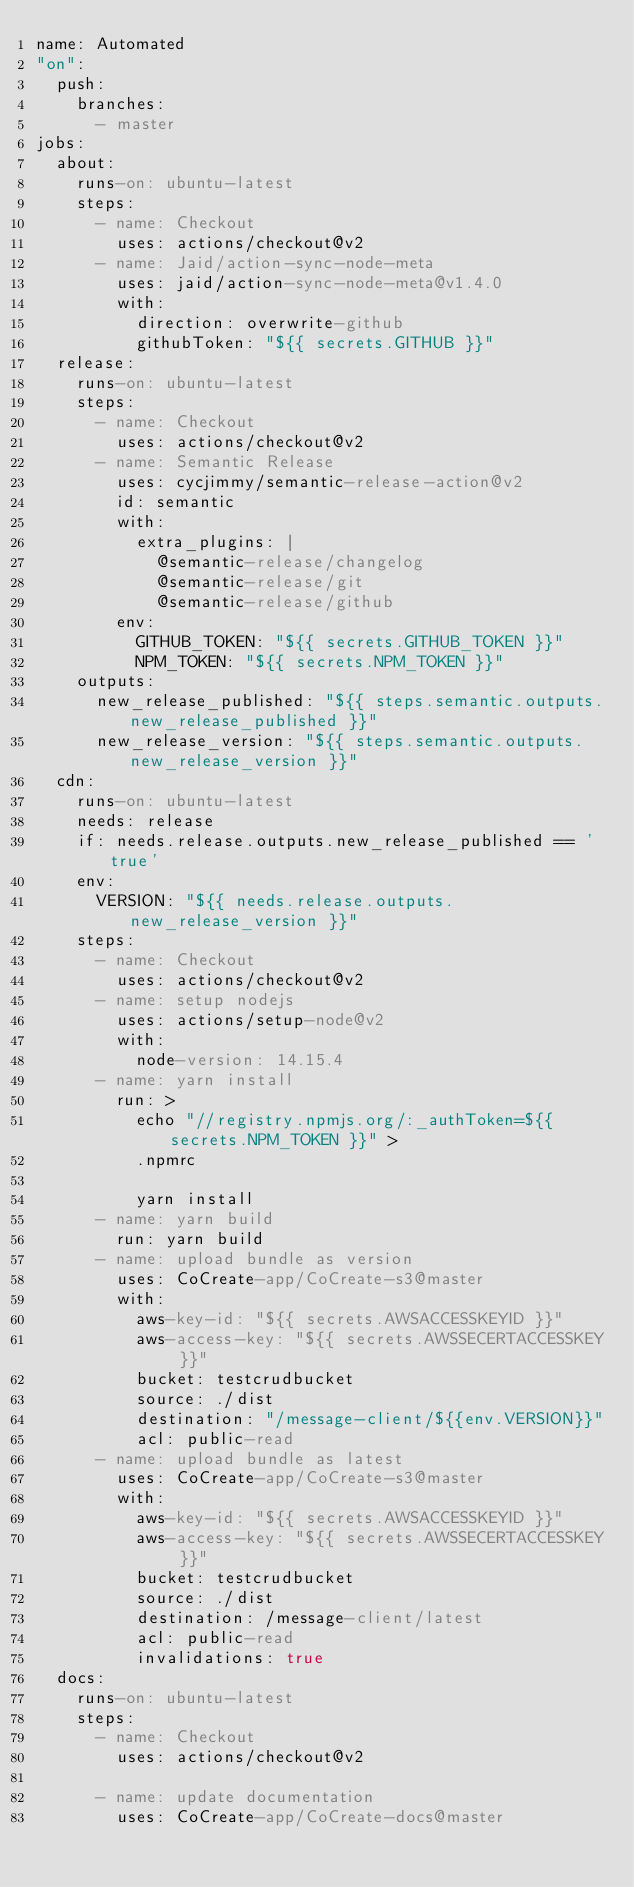Convert code to text. <code><loc_0><loc_0><loc_500><loc_500><_YAML_>name: Automated
"on":
  push:
    branches:
      - master
jobs:
  about:
    runs-on: ubuntu-latest
    steps:
      - name: Checkout
        uses: actions/checkout@v2
      - name: Jaid/action-sync-node-meta
        uses: jaid/action-sync-node-meta@v1.4.0
        with:
          direction: overwrite-github
          githubToken: "${{ secrets.GITHUB }}"
  release:
    runs-on: ubuntu-latest
    steps:
      - name: Checkout
        uses: actions/checkout@v2
      - name: Semantic Release
        uses: cycjimmy/semantic-release-action@v2
        id: semantic
        with:
          extra_plugins: |
            @semantic-release/changelog
            @semantic-release/git
            @semantic-release/github
        env:
          GITHUB_TOKEN: "${{ secrets.GITHUB_TOKEN }}"
          NPM_TOKEN: "${{ secrets.NPM_TOKEN }}"
    outputs:
      new_release_published: "${{ steps.semantic.outputs.new_release_published }}"
      new_release_version: "${{ steps.semantic.outputs.new_release_version }}"
  cdn:
    runs-on: ubuntu-latest
    needs: release
    if: needs.release.outputs.new_release_published == 'true'
    env:
      VERSION: "${{ needs.release.outputs.new_release_version }}"
    steps:
      - name: Checkout
        uses: actions/checkout@v2
      - name: setup nodejs
        uses: actions/setup-node@v2
        with:
          node-version: 14.15.4
      - name: yarn install
        run: >
          echo "//registry.npmjs.org/:_authToken=${{ secrets.NPM_TOKEN }}" >
          .npmrc

          yarn install
      - name: yarn build
        run: yarn build
      - name: upload bundle as version
        uses: CoCreate-app/CoCreate-s3@master
        with:
          aws-key-id: "${{ secrets.AWSACCESSKEYID }}"
          aws-access-key: "${{ secrets.AWSSECERTACCESSKEY }}"
          bucket: testcrudbucket
          source: ./dist
          destination: "/message-client/${{env.VERSION}}"
          acl: public-read
      - name: upload bundle as latest
        uses: CoCreate-app/CoCreate-s3@master
        with:
          aws-key-id: "${{ secrets.AWSACCESSKEYID }}"
          aws-access-key: "${{ secrets.AWSSECERTACCESSKEY }}"
          bucket: testcrudbucket
          source: ./dist
          destination: /message-client/latest
          acl: public-read
          invalidations: true
  docs:
    runs-on: ubuntu-latest
    steps:
      - name: Checkout
        uses: actions/checkout@v2

      - name: update documentation
        uses: CoCreate-app/CoCreate-docs@master
</code> 